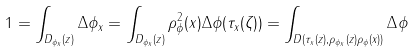<formula> <loc_0><loc_0><loc_500><loc_500>1 = \int _ { D _ { \phi _ { x } } ( z ) } \Delta \phi _ { x } = \int _ { D _ { \phi _ { x } } ( z ) } \rho ^ { 2 } _ { \phi } ( x ) \Delta \phi ( \tau _ { x } ( \zeta ) ) = \int _ { D ( \tau _ { x } ( z ) , \rho _ { \phi _ { x } } ( z ) \rho _ { \phi } ( x ) ) } \Delta \phi</formula> 